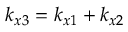Convert formula to latex. <formula><loc_0><loc_0><loc_500><loc_500>k _ { x 3 } = k _ { x 1 } + k _ { x 2 }</formula> 